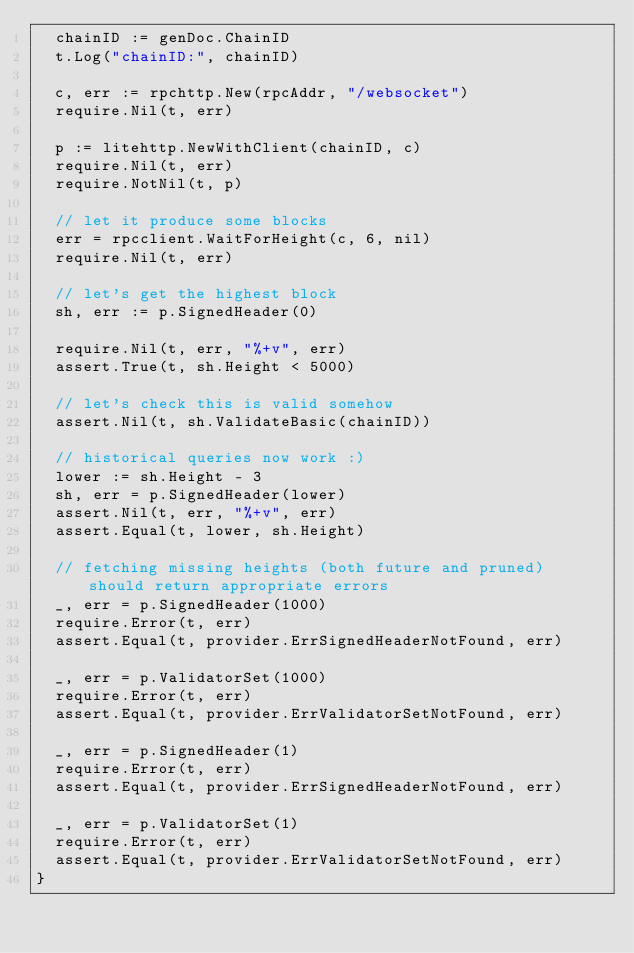<code> <loc_0><loc_0><loc_500><loc_500><_Go_>	chainID := genDoc.ChainID
	t.Log("chainID:", chainID)

	c, err := rpchttp.New(rpcAddr, "/websocket")
	require.Nil(t, err)

	p := litehttp.NewWithClient(chainID, c)
	require.Nil(t, err)
	require.NotNil(t, p)

	// let it produce some blocks
	err = rpcclient.WaitForHeight(c, 6, nil)
	require.Nil(t, err)

	// let's get the highest block
	sh, err := p.SignedHeader(0)

	require.Nil(t, err, "%+v", err)
	assert.True(t, sh.Height < 5000)

	// let's check this is valid somehow
	assert.Nil(t, sh.ValidateBasic(chainID))

	// historical queries now work :)
	lower := sh.Height - 3
	sh, err = p.SignedHeader(lower)
	assert.Nil(t, err, "%+v", err)
	assert.Equal(t, lower, sh.Height)

	// fetching missing heights (both future and pruned) should return appropriate errors
	_, err = p.SignedHeader(1000)
	require.Error(t, err)
	assert.Equal(t, provider.ErrSignedHeaderNotFound, err)

	_, err = p.ValidatorSet(1000)
	require.Error(t, err)
	assert.Equal(t, provider.ErrValidatorSetNotFound, err)

	_, err = p.SignedHeader(1)
	require.Error(t, err)
	assert.Equal(t, provider.ErrSignedHeaderNotFound, err)

	_, err = p.ValidatorSet(1)
	require.Error(t, err)
	assert.Equal(t, provider.ErrValidatorSetNotFound, err)
}
</code> 